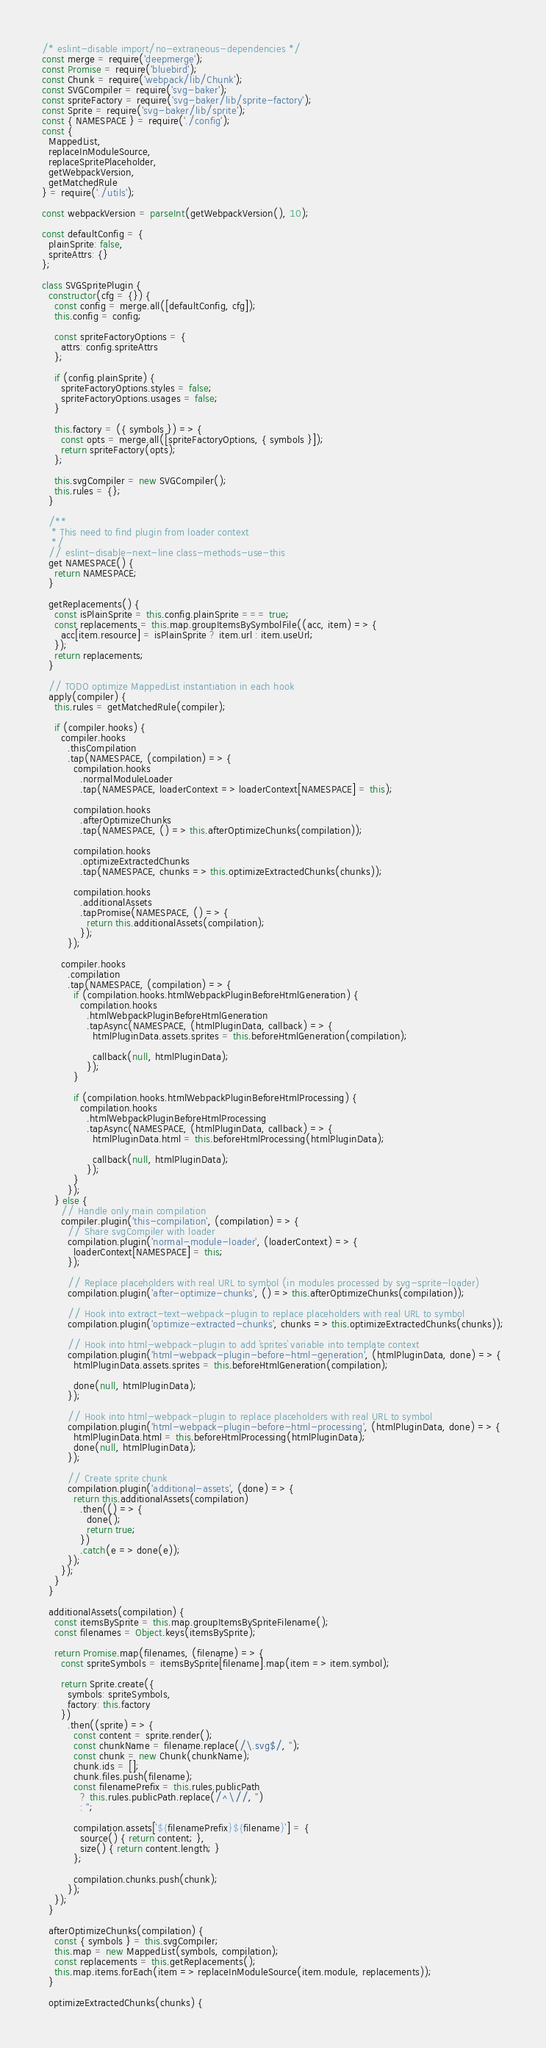Convert code to text. <code><loc_0><loc_0><loc_500><loc_500><_JavaScript_>/* eslint-disable import/no-extraneous-dependencies */
const merge = require('deepmerge');
const Promise = require('bluebird');
const Chunk = require('webpack/lib/Chunk');
const SVGCompiler = require('svg-baker');
const spriteFactory = require('svg-baker/lib/sprite-factory');
const Sprite = require('svg-baker/lib/sprite');
const { NAMESPACE } = require('./config');
const {
  MappedList,
  replaceInModuleSource,
  replaceSpritePlaceholder,
  getWebpackVersion,
  getMatchedRule
} = require('./utils');

const webpackVersion = parseInt(getWebpackVersion(), 10);

const defaultConfig = {
  plainSprite: false,
  spriteAttrs: {}
};

class SVGSpritePlugin {
  constructor(cfg = {}) {
    const config = merge.all([defaultConfig, cfg]);
    this.config = config;

    const spriteFactoryOptions = {
      attrs: config.spriteAttrs
    };

    if (config.plainSprite) {
      spriteFactoryOptions.styles = false;
      spriteFactoryOptions.usages = false;
    }

    this.factory = ({ symbols }) => {
      const opts = merge.all([spriteFactoryOptions, { symbols }]);
      return spriteFactory(opts);
    };

    this.svgCompiler = new SVGCompiler();
    this.rules = {};
  }

  /**
   * This need to find plugin from loader context
   */
  // eslint-disable-next-line class-methods-use-this
  get NAMESPACE() {
    return NAMESPACE;
  }

  getReplacements() {
    const isPlainSprite = this.config.plainSprite === true;
    const replacements = this.map.groupItemsBySymbolFile((acc, item) => {
      acc[item.resource] = isPlainSprite ? item.url : item.useUrl;
    });
    return replacements;
  }

  // TODO optimize MappedList instantiation in each hook
  apply(compiler) {
    this.rules = getMatchedRule(compiler);

    if (compiler.hooks) {
      compiler.hooks
        .thisCompilation
        .tap(NAMESPACE, (compilation) => {
          compilation.hooks
            .normalModuleLoader
            .tap(NAMESPACE, loaderContext => loaderContext[NAMESPACE] = this);

          compilation.hooks
            .afterOptimizeChunks
            .tap(NAMESPACE, () => this.afterOptimizeChunks(compilation));

          compilation.hooks
            .optimizeExtractedChunks
            .tap(NAMESPACE, chunks => this.optimizeExtractedChunks(chunks));

          compilation.hooks
            .additionalAssets
            .tapPromise(NAMESPACE, () => {
              return this.additionalAssets(compilation);
            });
        });

      compiler.hooks
        .compilation
        .tap(NAMESPACE, (compilation) => {
          if (compilation.hooks.htmlWebpackPluginBeforeHtmlGeneration) {
            compilation.hooks
              .htmlWebpackPluginBeforeHtmlGeneration
              .tapAsync(NAMESPACE, (htmlPluginData, callback) => {
                htmlPluginData.assets.sprites = this.beforeHtmlGeneration(compilation);

                callback(null, htmlPluginData);
              });
          }

          if (compilation.hooks.htmlWebpackPluginBeforeHtmlProcessing) {
            compilation.hooks
              .htmlWebpackPluginBeforeHtmlProcessing
              .tapAsync(NAMESPACE, (htmlPluginData, callback) => {
                htmlPluginData.html = this.beforeHtmlProcessing(htmlPluginData);

                callback(null, htmlPluginData);
              });
          }
        });
    } else {
      // Handle only main compilation
      compiler.plugin('this-compilation', (compilation) => {
        // Share svgCompiler with loader
        compilation.plugin('normal-module-loader', (loaderContext) => {
          loaderContext[NAMESPACE] = this;
        });

        // Replace placeholders with real URL to symbol (in modules processed by svg-sprite-loader)
        compilation.plugin('after-optimize-chunks', () => this.afterOptimizeChunks(compilation));

        // Hook into extract-text-webpack-plugin to replace placeholders with real URL to symbol
        compilation.plugin('optimize-extracted-chunks', chunks => this.optimizeExtractedChunks(chunks));

        // Hook into html-webpack-plugin to add `sprites` variable into template context
        compilation.plugin('html-webpack-plugin-before-html-generation', (htmlPluginData, done) => {
          htmlPluginData.assets.sprites = this.beforeHtmlGeneration(compilation);

          done(null, htmlPluginData);
        });

        // Hook into html-webpack-plugin to replace placeholders with real URL to symbol
        compilation.plugin('html-webpack-plugin-before-html-processing', (htmlPluginData, done) => {
          htmlPluginData.html = this.beforeHtmlProcessing(htmlPluginData);
          done(null, htmlPluginData);
        });

        // Create sprite chunk
        compilation.plugin('additional-assets', (done) => {
          return this.additionalAssets(compilation)
            .then(() => {
              done();
              return true;
            })
            .catch(e => done(e));
        });
      });
    }
  }

  additionalAssets(compilation) {
    const itemsBySprite = this.map.groupItemsBySpriteFilename();
    const filenames = Object.keys(itemsBySprite);

    return Promise.map(filenames, (filename) => {
      const spriteSymbols = itemsBySprite[filename].map(item => item.symbol);

      return Sprite.create({
        symbols: spriteSymbols,
        factory: this.factory
      })
        .then((sprite) => {
          const content = sprite.render();
          const chunkName = filename.replace(/\.svg$/, '');
          const chunk = new Chunk(chunkName);
          chunk.ids = [];
          chunk.files.push(filename);
          const filenamePrefix = this.rules.publicPath
            ? this.rules.publicPath.replace(/^\//, '')
            : '';

          compilation.assets[`${filenamePrefix}${filename}`] = {
            source() { return content; },
            size() { return content.length; }
          };

          compilation.chunks.push(chunk);
        });
    });
  }

  afterOptimizeChunks(compilation) {
    const { symbols } = this.svgCompiler;
    this.map = new MappedList(symbols, compilation);
    const replacements = this.getReplacements();
    this.map.items.forEach(item => replaceInModuleSource(item.module, replacements));
  }

  optimizeExtractedChunks(chunks) {</code> 